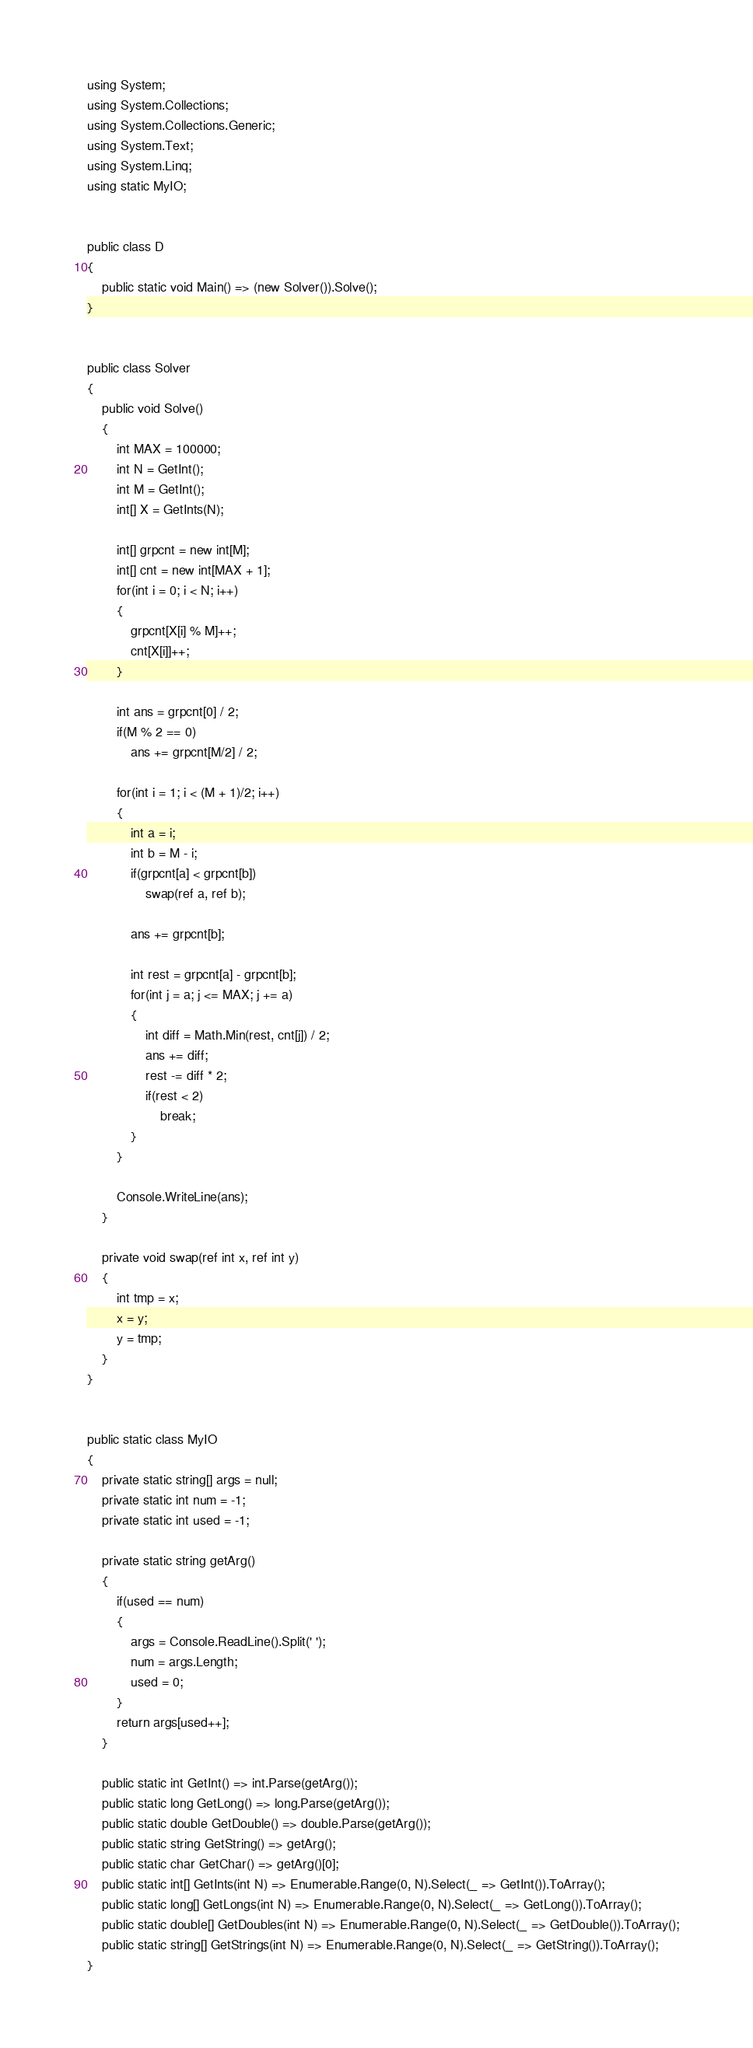Convert code to text. <code><loc_0><loc_0><loc_500><loc_500><_C#_>using System;
using System.Collections;
using System.Collections.Generic;
using System.Text;
using System.Linq;
using static MyIO;


public class D
{
	public static void Main() => (new Solver()).Solve();
}


public class Solver
{
	public void Solve()
	{
		int MAX = 100000;
		int N = GetInt();
		int M = GetInt();
		int[] X = GetInts(N);

		int[] grpcnt = new int[M];
		int[] cnt = new int[MAX + 1];
		for(int i = 0; i < N; i++)
		{
			grpcnt[X[i] % M]++;
			cnt[X[i]]++;
		}

		int ans = grpcnt[0] / 2;
		if(M % 2 == 0)
			ans += grpcnt[M/2] / 2;

		for(int i = 1; i < (M + 1)/2; i++)
		{
			int a = i;
			int b = M - i;
			if(grpcnt[a] < grpcnt[b])
				swap(ref a, ref b);

			ans += grpcnt[b];

			int rest = grpcnt[a] - grpcnt[b];
			for(int j = a; j <= MAX; j += a)
			{
				int diff = Math.Min(rest, cnt[j]) / 2;
				ans += diff;
				rest -= diff * 2;
				if(rest < 2)
					break;
			}
		}

		Console.WriteLine(ans);
	}

	private void swap(ref int x, ref int y)
	{
		int tmp = x;
		x = y;
		y = tmp;
	}
}


public static class MyIO
{
	private static string[] args = null;
	private static int num = -1;
	private static int used = -1;

	private static string getArg()
	{
		if(used == num)
		{
			args = Console.ReadLine().Split(' ');
			num = args.Length;
			used = 0;
		}
		return args[used++];
	}

	public static int GetInt() => int.Parse(getArg());
	public static long GetLong() => long.Parse(getArg());
	public static double GetDouble() => double.Parse(getArg());
	public static string GetString() => getArg();
	public static char GetChar() => getArg()[0];
	public static int[] GetInts(int N) => Enumerable.Range(0, N).Select(_ => GetInt()).ToArray();
	public static long[] GetLongs(int N) => Enumerable.Range(0, N).Select(_ => GetLong()).ToArray();
	public static double[] GetDoubles(int N) => Enumerable.Range(0, N).Select(_ => GetDouble()).ToArray();
	public static string[] GetStrings(int N) => Enumerable.Range(0, N).Select(_ => GetString()).ToArray();
}
</code> 